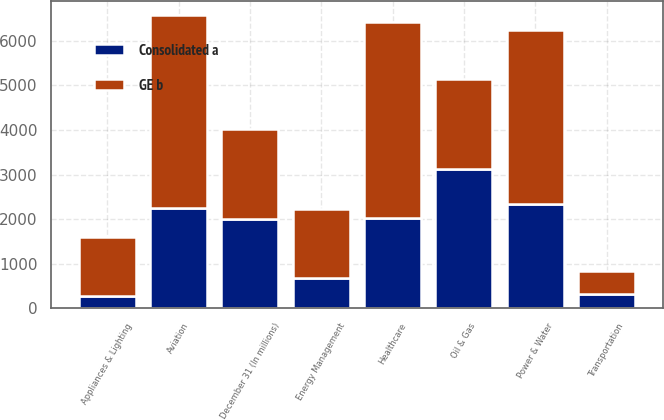Convert chart. <chart><loc_0><loc_0><loc_500><loc_500><stacked_bar_chart><ecel><fcel>December 31 (In millions)<fcel>Power & Water<fcel>Oil & Gas<fcel>Energy Management<fcel>Aviation<fcel>Healthcare<fcel>Transportation<fcel>Appliances & Lighting<nl><fcel>GE b<fcel>2013<fcel>3895<fcel>2013<fcel>1540<fcel>4307<fcel>4398<fcel>526<fcel>1337<nl><fcel>Consolidated a<fcel>2013<fcel>2335<fcel>3134<fcel>686<fcel>2260<fcel>2029<fcel>318<fcel>273<nl></chart> 